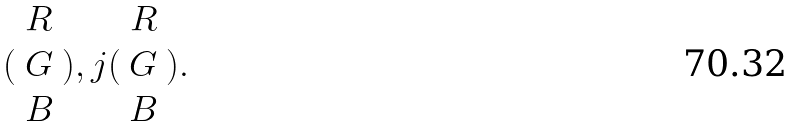<formula> <loc_0><loc_0><loc_500><loc_500>( \begin{array} { c } R \\ G \\ B \end{array} ) , j ( \begin{array} { c } R \\ G \\ B \end{array} ) .</formula> 